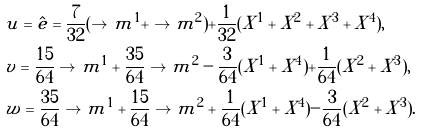Convert formula to latex. <formula><loc_0><loc_0><loc_500><loc_500>& u = \hat { e } = \frac { 7 } { 3 2 } ( \to m ^ { 1 } + \to m ^ { 2 } ) + \frac { 1 } { 3 2 } ( X ^ { 1 } + X ^ { 2 } + X ^ { 3 } + X ^ { 4 } ) , \\ & v = \frac { 1 5 } { 6 4 } \to m ^ { 1 } + \frac { 3 5 } { 6 4 } \to m ^ { 2 } - \frac { 3 } { 6 4 } ( X ^ { 1 } + X ^ { 4 } ) + \frac { 1 } { 6 4 } ( X ^ { 2 } + X ^ { 3 } ) , \\ & w = \frac { 3 5 } { 6 4 } \to m ^ { 1 } + \frac { 1 5 } { 6 4 } \to m ^ { 2 } + \frac { 1 } { 6 4 } ( X ^ { 1 } + X ^ { 4 } ) - \frac { 3 } { 6 4 } ( X ^ { 2 } + X ^ { 3 } ) .</formula> 